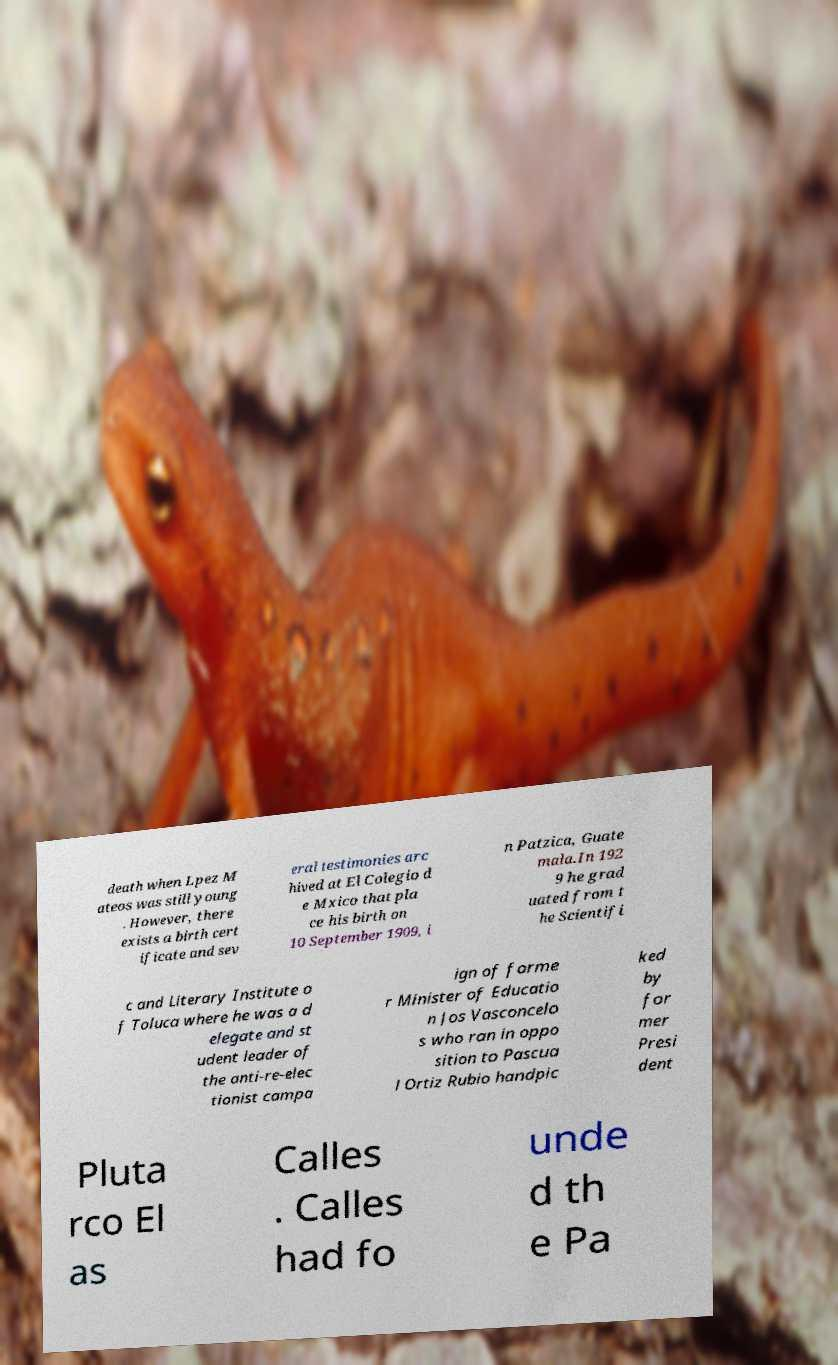Please read and relay the text visible in this image. What does it say? death when Lpez M ateos was still young . However, there exists a birth cert ificate and sev eral testimonies arc hived at El Colegio d e Mxico that pla ce his birth on 10 September 1909, i n Patzica, Guate mala.In 192 9 he grad uated from t he Scientifi c and Literary Institute o f Toluca where he was a d elegate and st udent leader of the anti-re-elec tionist campa ign of forme r Minister of Educatio n Jos Vasconcelo s who ran in oppo sition to Pascua l Ortiz Rubio handpic ked by for mer Presi dent Pluta rco El as Calles . Calles had fo unde d th e Pa 